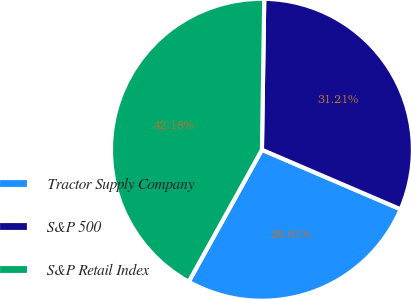<chart> <loc_0><loc_0><loc_500><loc_500><pie_chart><fcel>Tractor Supply Company<fcel>S&P 500<fcel>S&P Retail Index<nl><fcel>26.61%<fcel>31.21%<fcel>42.18%<nl></chart> 